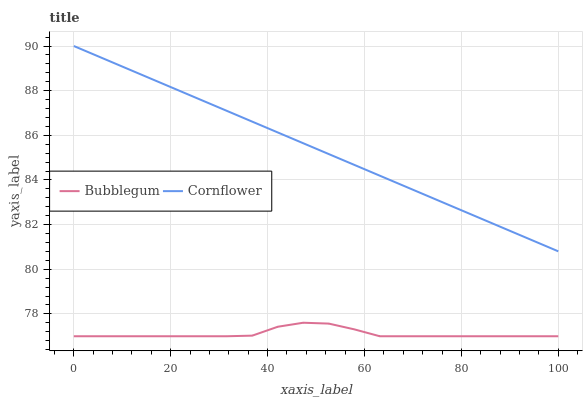Does Bubblegum have the minimum area under the curve?
Answer yes or no. Yes. Does Cornflower have the maximum area under the curve?
Answer yes or no. Yes. Does Bubblegum have the maximum area under the curve?
Answer yes or no. No. Is Cornflower the smoothest?
Answer yes or no. Yes. Is Bubblegum the roughest?
Answer yes or no. Yes. Is Bubblegum the smoothest?
Answer yes or no. No. Does Bubblegum have the lowest value?
Answer yes or no. Yes. Does Cornflower have the highest value?
Answer yes or no. Yes. Does Bubblegum have the highest value?
Answer yes or no. No. Is Bubblegum less than Cornflower?
Answer yes or no. Yes. Is Cornflower greater than Bubblegum?
Answer yes or no. Yes. Does Bubblegum intersect Cornflower?
Answer yes or no. No. 